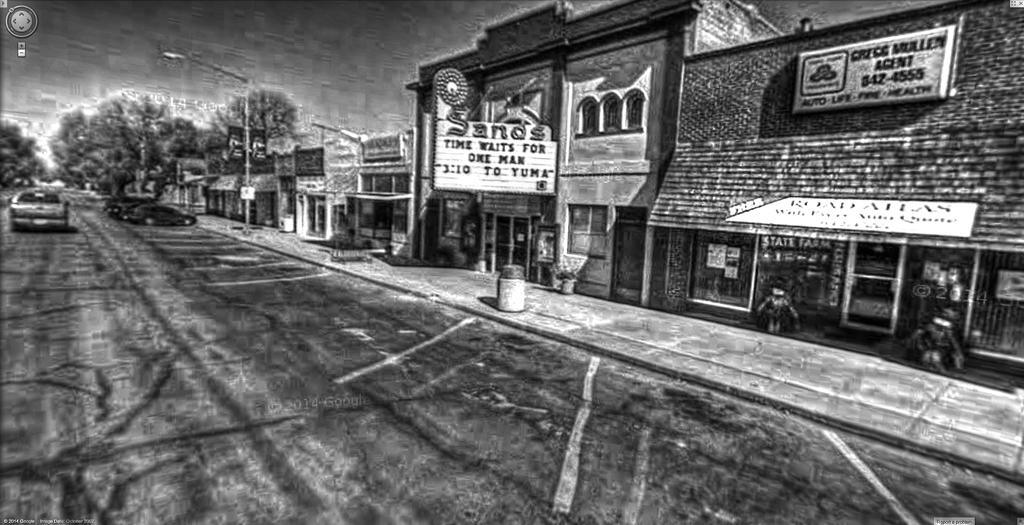Provide a one-sentence caption for the provided image. Sands movie theatre is playing 3:10 to Yuma on the screen. 